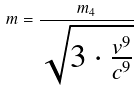<formula> <loc_0><loc_0><loc_500><loc_500>m = \frac { m _ { 4 } } { \sqrt { 3 \cdot \frac { v ^ { 9 } } { c ^ { 9 } } } }</formula> 